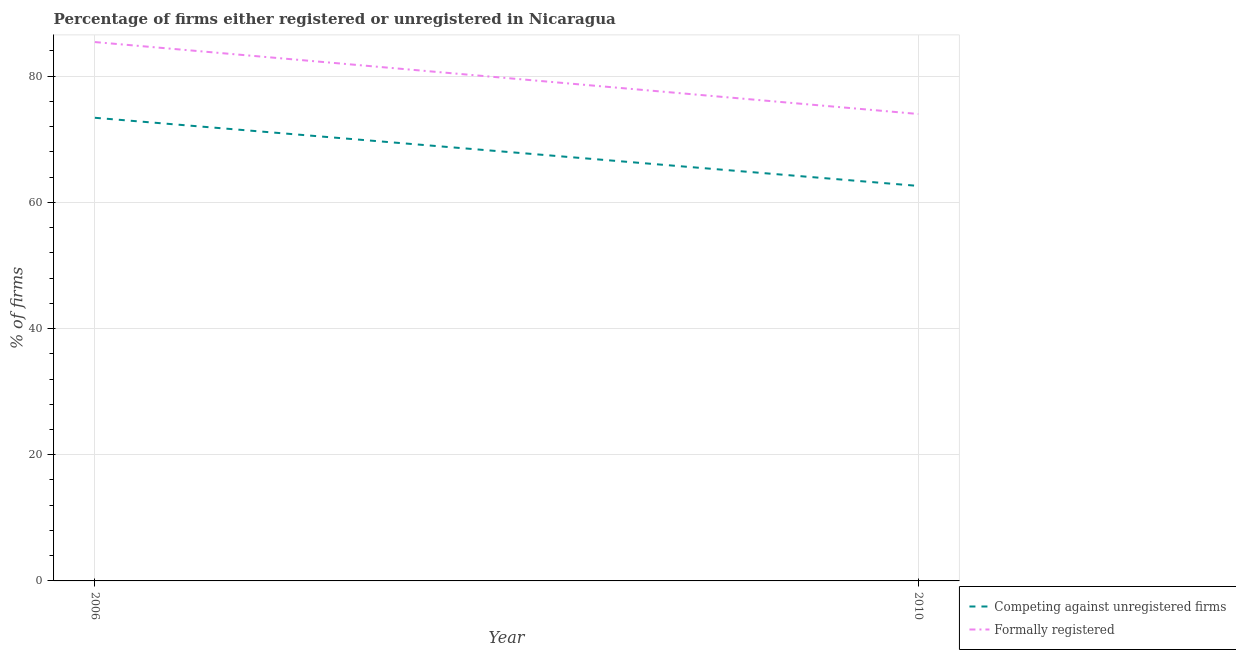How many different coloured lines are there?
Your answer should be compact. 2. What is the percentage of registered firms in 2006?
Keep it short and to the point. 73.4. Across all years, what is the maximum percentage of formally registered firms?
Your response must be concise. 85.4. In which year was the percentage of registered firms maximum?
Your answer should be very brief. 2006. In which year was the percentage of registered firms minimum?
Offer a very short reply. 2010. What is the total percentage of registered firms in the graph?
Ensure brevity in your answer.  136. What is the difference between the percentage of formally registered firms in 2006 and that in 2010?
Your response must be concise. 11.4. What is the difference between the percentage of registered firms in 2006 and the percentage of formally registered firms in 2010?
Your answer should be very brief. -0.6. In the year 2010, what is the difference between the percentage of formally registered firms and percentage of registered firms?
Keep it short and to the point. 11.4. In how many years, is the percentage of registered firms greater than 60 %?
Offer a terse response. 2. What is the ratio of the percentage of formally registered firms in 2006 to that in 2010?
Offer a terse response. 1.15. Is the percentage of registered firms in 2006 less than that in 2010?
Keep it short and to the point. No. In how many years, is the percentage of formally registered firms greater than the average percentage of formally registered firms taken over all years?
Offer a very short reply. 1. How many lines are there?
Ensure brevity in your answer.  2. Does the graph contain grids?
Your answer should be compact. Yes. Where does the legend appear in the graph?
Your answer should be compact. Bottom right. How many legend labels are there?
Make the answer very short. 2. How are the legend labels stacked?
Keep it short and to the point. Vertical. What is the title of the graph?
Give a very brief answer. Percentage of firms either registered or unregistered in Nicaragua. What is the label or title of the X-axis?
Offer a very short reply. Year. What is the label or title of the Y-axis?
Your answer should be very brief. % of firms. What is the % of firms of Competing against unregistered firms in 2006?
Offer a terse response. 73.4. What is the % of firms of Formally registered in 2006?
Provide a short and direct response. 85.4. What is the % of firms in Competing against unregistered firms in 2010?
Keep it short and to the point. 62.6. What is the % of firms of Formally registered in 2010?
Your response must be concise. 74. Across all years, what is the maximum % of firms of Competing against unregistered firms?
Provide a short and direct response. 73.4. Across all years, what is the maximum % of firms of Formally registered?
Offer a very short reply. 85.4. Across all years, what is the minimum % of firms of Competing against unregistered firms?
Provide a succinct answer. 62.6. Across all years, what is the minimum % of firms of Formally registered?
Your answer should be compact. 74. What is the total % of firms of Competing against unregistered firms in the graph?
Keep it short and to the point. 136. What is the total % of firms of Formally registered in the graph?
Your answer should be very brief. 159.4. What is the difference between the % of firms in Competing against unregistered firms in 2006 and that in 2010?
Keep it short and to the point. 10.8. What is the average % of firms of Competing against unregistered firms per year?
Your response must be concise. 68. What is the average % of firms of Formally registered per year?
Provide a short and direct response. 79.7. In the year 2006, what is the difference between the % of firms of Competing against unregistered firms and % of firms of Formally registered?
Your answer should be very brief. -12. What is the ratio of the % of firms of Competing against unregistered firms in 2006 to that in 2010?
Offer a very short reply. 1.17. What is the ratio of the % of firms of Formally registered in 2006 to that in 2010?
Offer a very short reply. 1.15. What is the difference between the highest and the second highest % of firms of Competing against unregistered firms?
Ensure brevity in your answer.  10.8. What is the difference between the highest and the second highest % of firms of Formally registered?
Offer a very short reply. 11.4. What is the difference between the highest and the lowest % of firms in Competing against unregistered firms?
Offer a terse response. 10.8. What is the difference between the highest and the lowest % of firms in Formally registered?
Your answer should be very brief. 11.4. 